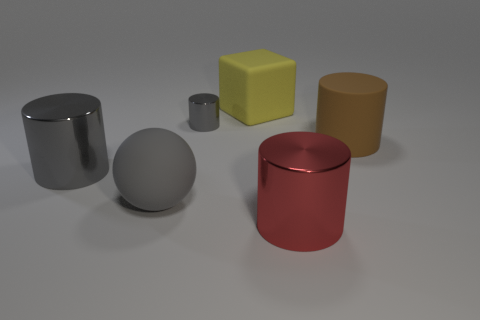Subtract all green cylinders. Subtract all cyan cubes. How many cylinders are left? 4 Add 3 large brown things. How many objects exist? 9 Subtract all cylinders. How many objects are left? 2 Add 5 big cylinders. How many big cylinders are left? 8 Add 4 red metallic objects. How many red metallic objects exist? 5 Subtract 1 yellow cubes. How many objects are left? 5 Subtract all cylinders. Subtract all big brown objects. How many objects are left? 1 